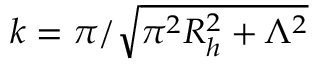<formula> <loc_0><loc_0><loc_500><loc_500>k = \pi / \sqrt { \pi ^ { 2 } R _ { h } ^ { 2 } + \Lambda ^ { 2 } }</formula> 